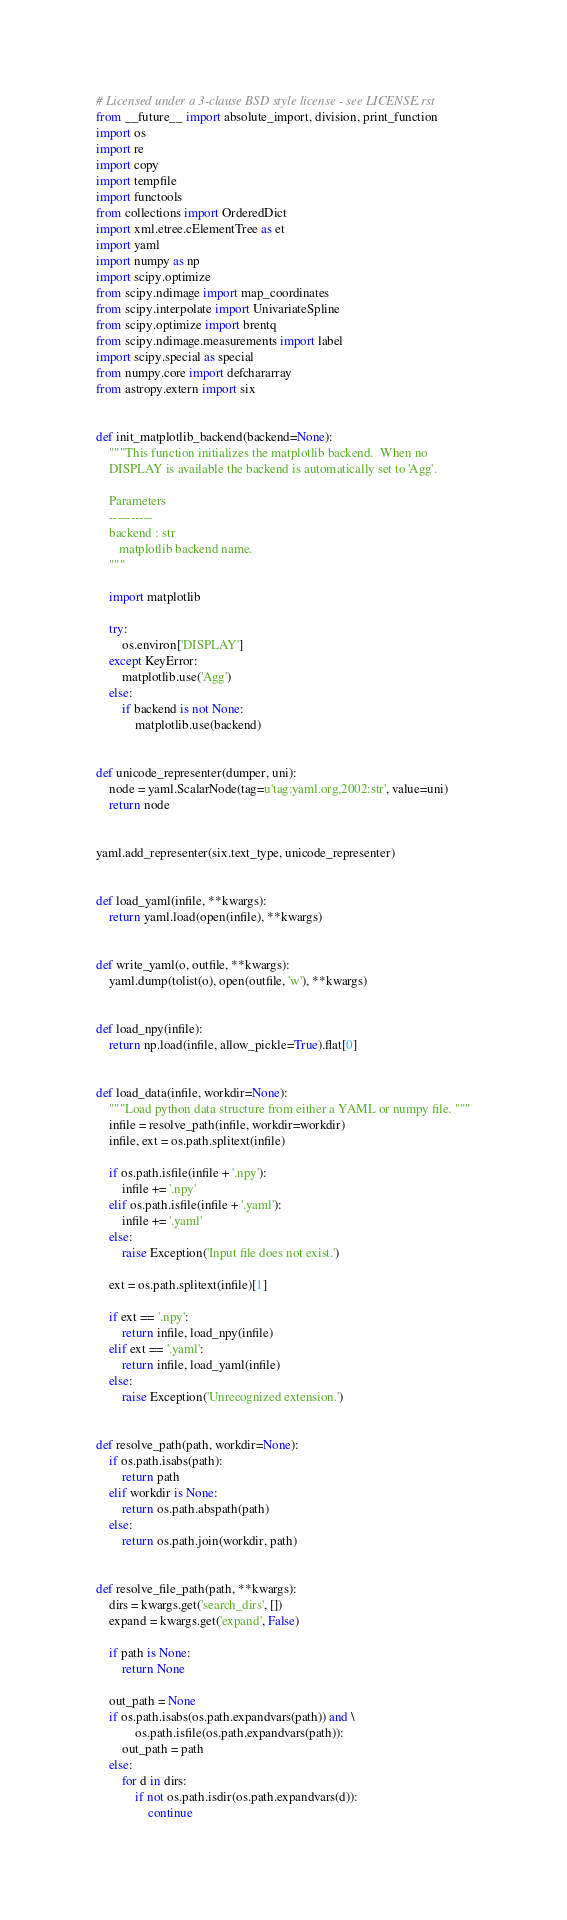<code> <loc_0><loc_0><loc_500><loc_500><_Python_># Licensed under a 3-clause BSD style license - see LICENSE.rst
from __future__ import absolute_import, division, print_function
import os
import re
import copy
import tempfile
import functools
from collections import OrderedDict
import xml.etree.cElementTree as et
import yaml
import numpy as np
import scipy.optimize
from scipy.ndimage import map_coordinates
from scipy.interpolate import UnivariateSpline
from scipy.optimize import brentq
from scipy.ndimage.measurements import label
import scipy.special as special
from numpy.core import defchararray
from astropy.extern import six


def init_matplotlib_backend(backend=None):
    """This function initializes the matplotlib backend.  When no
    DISPLAY is available the backend is automatically set to 'Agg'.

    Parameters
    ----------
    backend : str
       matplotlib backend name.
    """

    import matplotlib

    try:
        os.environ['DISPLAY']
    except KeyError:
        matplotlib.use('Agg')
    else:
        if backend is not None:
            matplotlib.use(backend)


def unicode_representer(dumper, uni):
    node = yaml.ScalarNode(tag=u'tag:yaml.org,2002:str', value=uni)
    return node


yaml.add_representer(six.text_type, unicode_representer)


def load_yaml(infile, **kwargs):
    return yaml.load(open(infile), **kwargs)


def write_yaml(o, outfile, **kwargs):
    yaml.dump(tolist(o), open(outfile, 'w'), **kwargs)


def load_npy(infile):
    return np.load(infile, allow_pickle=True).flat[0]


def load_data(infile, workdir=None):
    """Load python data structure from either a YAML or numpy file. """
    infile = resolve_path(infile, workdir=workdir)
    infile, ext = os.path.splitext(infile)

    if os.path.isfile(infile + '.npy'):
        infile += '.npy'
    elif os.path.isfile(infile + '.yaml'):
        infile += '.yaml'
    else:
        raise Exception('Input file does not exist.')

    ext = os.path.splitext(infile)[1]

    if ext == '.npy':
        return infile, load_npy(infile)
    elif ext == '.yaml':
        return infile, load_yaml(infile)
    else:
        raise Exception('Unrecognized extension.')


def resolve_path(path, workdir=None):
    if os.path.isabs(path):
        return path
    elif workdir is None:
        return os.path.abspath(path)
    else:
        return os.path.join(workdir, path)


def resolve_file_path(path, **kwargs):
    dirs = kwargs.get('search_dirs', [])
    expand = kwargs.get('expand', False)

    if path is None:
        return None

    out_path = None
    if os.path.isabs(os.path.expandvars(path)) and \
            os.path.isfile(os.path.expandvars(path)):
        out_path = path
    else:
        for d in dirs:
            if not os.path.isdir(os.path.expandvars(d)):
                continue</code> 